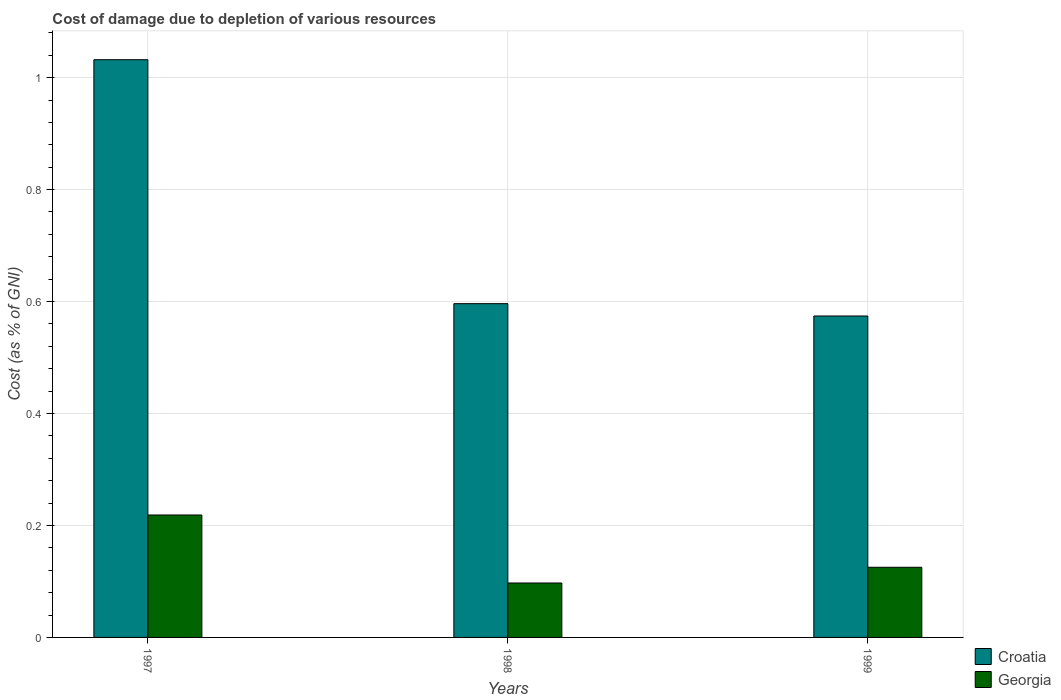How many different coloured bars are there?
Ensure brevity in your answer.  2. Are the number of bars per tick equal to the number of legend labels?
Your response must be concise. Yes. Are the number of bars on each tick of the X-axis equal?
Offer a very short reply. Yes. How many bars are there on the 2nd tick from the right?
Keep it short and to the point. 2. In how many cases, is the number of bars for a given year not equal to the number of legend labels?
Offer a very short reply. 0. What is the cost of damage caused due to the depletion of various resources in Croatia in 1997?
Your response must be concise. 1.03. Across all years, what is the maximum cost of damage caused due to the depletion of various resources in Croatia?
Ensure brevity in your answer.  1.03. Across all years, what is the minimum cost of damage caused due to the depletion of various resources in Croatia?
Provide a short and direct response. 0.57. In which year was the cost of damage caused due to the depletion of various resources in Croatia minimum?
Your answer should be very brief. 1999. What is the total cost of damage caused due to the depletion of various resources in Croatia in the graph?
Offer a terse response. 2.2. What is the difference between the cost of damage caused due to the depletion of various resources in Georgia in 1997 and that in 1998?
Your answer should be compact. 0.12. What is the difference between the cost of damage caused due to the depletion of various resources in Georgia in 1998 and the cost of damage caused due to the depletion of various resources in Croatia in 1999?
Provide a short and direct response. -0.48. What is the average cost of damage caused due to the depletion of various resources in Croatia per year?
Provide a short and direct response. 0.73. In the year 1998, what is the difference between the cost of damage caused due to the depletion of various resources in Georgia and cost of damage caused due to the depletion of various resources in Croatia?
Your answer should be compact. -0.5. In how many years, is the cost of damage caused due to the depletion of various resources in Georgia greater than 0.56 %?
Make the answer very short. 0. What is the ratio of the cost of damage caused due to the depletion of various resources in Georgia in 1998 to that in 1999?
Offer a very short reply. 0.78. Is the cost of damage caused due to the depletion of various resources in Georgia in 1998 less than that in 1999?
Ensure brevity in your answer.  Yes. Is the difference between the cost of damage caused due to the depletion of various resources in Georgia in 1997 and 1998 greater than the difference between the cost of damage caused due to the depletion of various resources in Croatia in 1997 and 1998?
Provide a short and direct response. No. What is the difference between the highest and the second highest cost of damage caused due to the depletion of various resources in Georgia?
Your answer should be compact. 0.09. What is the difference between the highest and the lowest cost of damage caused due to the depletion of various resources in Croatia?
Your answer should be very brief. 0.46. Is the sum of the cost of damage caused due to the depletion of various resources in Georgia in 1997 and 1999 greater than the maximum cost of damage caused due to the depletion of various resources in Croatia across all years?
Your answer should be very brief. No. What does the 2nd bar from the left in 1998 represents?
Provide a short and direct response. Georgia. What does the 1st bar from the right in 1999 represents?
Your answer should be compact. Georgia. Are all the bars in the graph horizontal?
Keep it short and to the point. No. What is the difference between two consecutive major ticks on the Y-axis?
Offer a very short reply. 0.2. Are the values on the major ticks of Y-axis written in scientific E-notation?
Give a very brief answer. No. Does the graph contain any zero values?
Your answer should be very brief. No. Does the graph contain grids?
Offer a terse response. Yes. Where does the legend appear in the graph?
Provide a succinct answer. Bottom right. How many legend labels are there?
Give a very brief answer. 2. What is the title of the graph?
Provide a short and direct response. Cost of damage due to depletion of various resources. Does "Cyprus" appear as one of the legend labels in the graph?
Give a very brief answer. No. What is the label or title of the X-axis?
Provide a succinct answer. Years. What is the label or title of the Y-axis?
Offer a terse response. Cost (as % of GNI). What is the Cost (as % of GNI) in Croatia in 1997?
Offer a very short reply. 1.03. What is the Cost (as % of GNI) in Georgia in 1997?
Offer a terse response. 0.22. What is the Cost (as % of GNI) in Croatia in 1998?
Keep it short and to the point. 0.6. What is the Cost (as % of GNI) in Georgia in 1998?
Make the answer very short. 0.1. What is the Cost (as % of GNI) of Croatia in 1999?
Keep it short and to the point. 0.57. What is the Cost (as % of GNI) of Georgia in 1999?
Your answer should be compact. 0.13. Across all years, what is the maximum Cost (as % of GNI) of Croatia?
Keep it short and to the point. 1.03. Across all years, what is the maximum Cost (as % of GNI) of Georgia?
Your answer should be compact. 0.22. Across all years, what is the minimum Cost (as % of GNI) of Croatia?
Provide a succinct answer. 0.57. Across all years, what is the minimum Cost (as % of GNI) of Georgia?
Provide a short and direct response. 0.1. What is the total Cost (as % of GNI) of Croatia in the graph?
Ensure brevity in your answer.  2.2. What is the total Cost (as % of GNI) of Georgia in the graph?
Provide a succinct answer. 0.44. What is the difference between the Cost (as % of GNI) in Croatia in 1997 and that in 1998?
Keep it short and to the point. 0.44. What is the difference between the Cost (as % of GNI) in Georgia in 1997 and that in 1998?
Offer a very short reply. 0.12. What is the difference between the Cost (as % of GNI) of Croatia in 1997 and that in 1999?
Give a very brief answer. 0.46. What is the difference between the Cost (as % of GNI) in Georgia in 1997 and that in 1999?
Ensure brevity in your answer.  0.09. What is the difference between the Cost (as % of GNI) in Croatia in 1998 and that in 1999?
Offer a terse response. 0.02. What is the difference between the Cost (as % of GNI) in Georgia in 1998 and that in 1999?
Provide a succinct answer. -0.03. What is the difference between the Cost (as % of GNI) of Croatia in 1997 and the Cost (as % of GNI) of Georgia in 1998?
Your answer should be very brief. 0.93. What is the difference between the Cost (as % of GNI) of Croatia in 1997 and the Cost (as % of GNI) of Georgia in 1999?
Offer a terse response. 0.91. What is the difference between the Cost (as % of GNI) in Croatia in 1998 and the Cost (as % of GNI) in Georgia in 1999?
Keep it short and to the point. 0.47. What is the average Cost (as % of GNI) in Croatia per year?
Keep it short and to the point. 0.73. What is the average Cost (as % of GNI) in Georgia per year?
Your answer should be compact. 0.15. In the year 1997, what is the difference between the Cost (as % of GNI) of Croatia and Cost (as % of GNI) of Georgia?
Provide a short and direct response. 0.81. In the year 1998, what is the difference between the Cost (as % of GNI) in Croatia and Cost (as % of GNI) in Georgia?
Give a very brief answer. 0.5. In the year 1999, what is the difference between the Cost (as % of GNI) of Croatia and Cost (as % of GNI) of Georgia?
Your answer should be very brief. 0.45. What is the ratio of the Cost (as % of GNI) of Croatia in 1997 to that in 1998?
Make the answer very short. 1.73. What is the ratio of the Cost (as % of GNI) in Georgia in 1997 to that in 1998?
Ensure brevity in your answer.  2.25. What is the ratio of the Cost (as % of GNI) in Croatia in 1997 to that in 1999?
Your answer should be compact. 1.8. What is the ratio of the Cost (as % of GNI) in Georgia in 1997 to that in 1999?
Your response must be concise. 1.75. What is the ratio of the Cost (as % of GNI) of Croatia in 1998 to that in 1999?
Provide a succinct answer. 1.04. What is the ratio of the Cost (as % of GNI) of Georgia in 1998 to that in 1999?
Offer a very short reply. 0.78. What is the difference between the highest and the second highest Cost (as % of GNI) of Croatia?
Make the answer very short. 0.44. What is the difference between the highest and the second highest Cost (as % of GNI) of Georgia?
Make the answer very short. 0.09. What is the difference between the highest and the lowest Cost (as % of GNI) in Croatia?
Your answer should be very brief. 0.46. What is the difference between the highest and the lowest Cost (as % of GNI) in Georgia?
Make the answer very short. 0.12. 